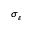<formula> <loc_0><loc_0><loc_500><loc_500>\sigma _ { \varepsilon }</formula> 